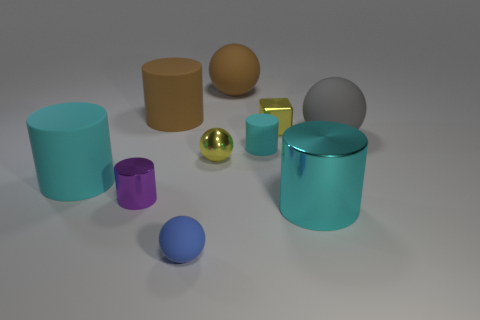Could you tell me the colors of all the objects seen in this image? Certainly! Starting from the left, there is a cyan cylinder, a beige cylinder, a brownish-beige sphere, a golden-yellow shiny sphere, a silver sphere, a small violet cylinder, a blue sphere, and a teal blue cylinder. 